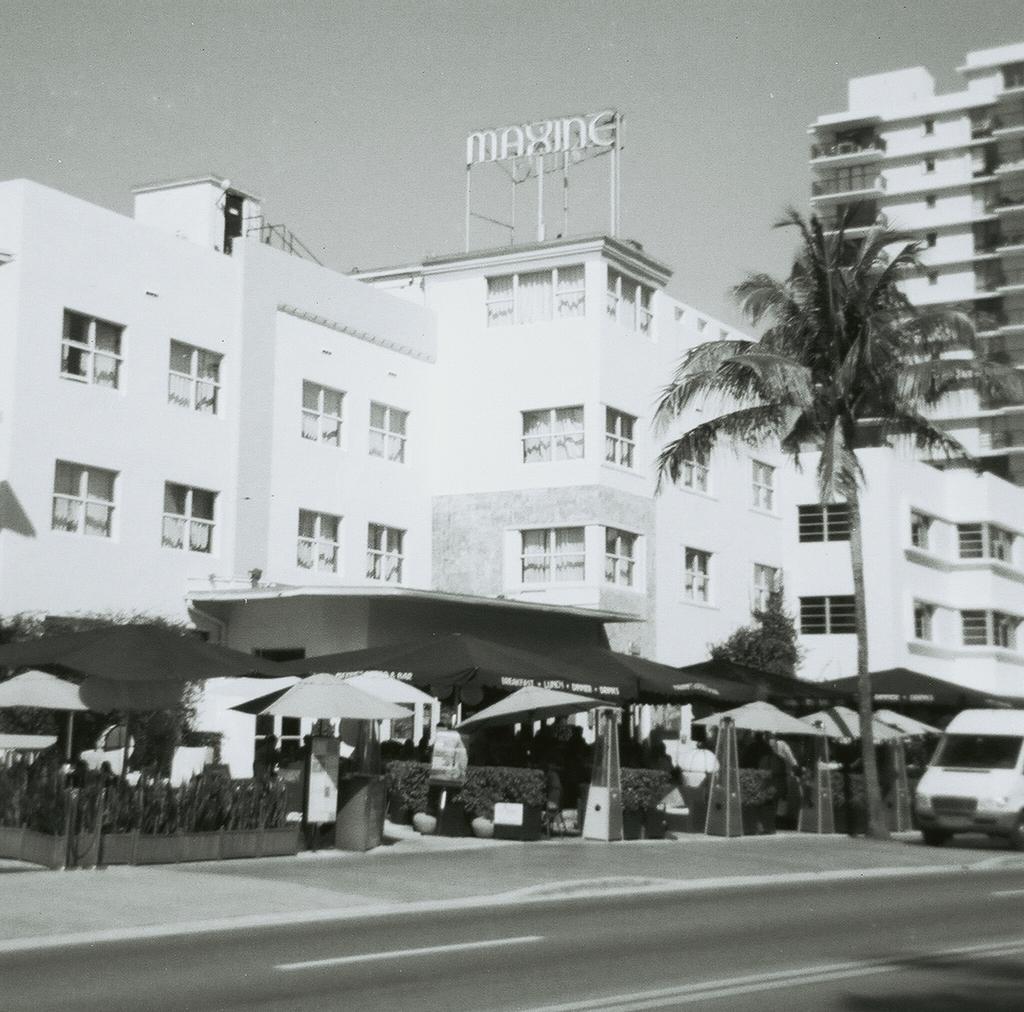Could you give a brief overview of what you see in this image? In this image, we can see so many buildings, windows, trees, plants, umbrellas. At the bottom, there is a road. Right side of the image, we can see a vehicle. Top of the image, there is a sky. 